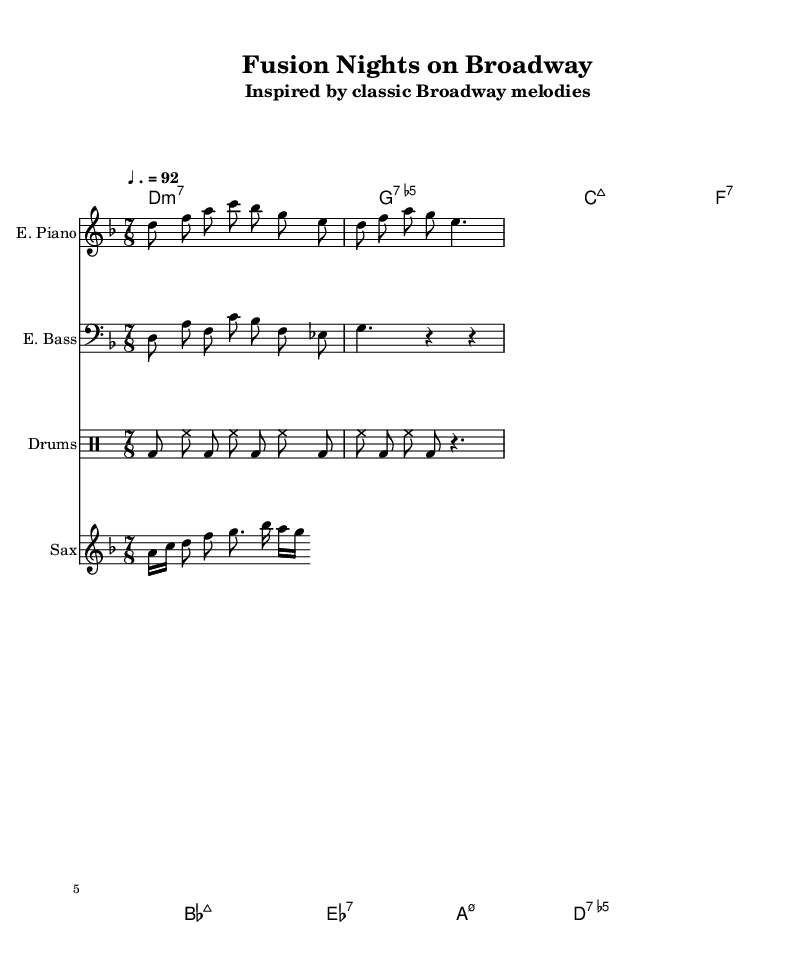What is the key signature of this music? The key signature is D minor, which has one flat (B flat). This can be identified by looking at the beginning of the staff, where the key signature is indicated.
Answer: D minor What is the time signature of this music? The time signature is seven-eighths (7/8), which indicates that there are seven beats in each measure and each beat is an eighth note. This is shown at the beginning of the score following the clef.
Answer: 7/8 What is the tempo marking of this music? The tempo marking is ♩. = 92, indicating that the quarter note should be played at a speed of 92 beats per minute. This is typically found at the start of the score close to the time signature.
Answer: 92 What is the texture of the instrumentation used in this piece? The instrumentation includes electric piano, electric bass, drums, and saxophone. This can be determined by reviewing the individual staff labels and the instruments indicated at the beginning of each staff.
Answer: Electric piano, electric bass, drums, saxophone Which chord appears most frequently in the chord progression? The D minor seventh chord appears most frequently in the progression. By examining the chord names listed, it is evident that D minor seventh is played in several measures.
Answer: D minor seventh What is the most complex rhythmic subdivision found in this score? The most complex rhythmic subdivision is the sixteenth note pattern exhibited in the saxophone part. This can be observed in the saxophone line where sixteenth notes create a faster rhythmic texture.
Answer: Sixteenth notes How does the use of 7/8 time signature influence the feel of the piece? The 7/8 time signature creates an off-kilter and syncopated feel, which evokes a sense of unpredictability and excitement, distinguishing it from more conventional time signatures typically found in Broadway music. This influence can be analyzed by examining the overall structure and accented beats in the score.
Answer: Syncopated feel 